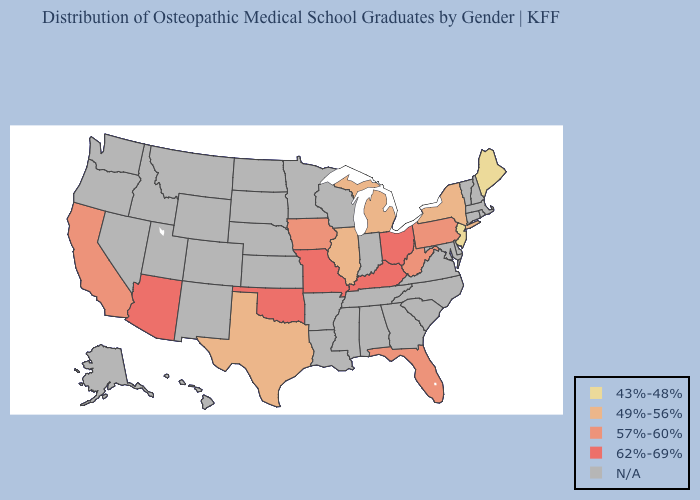What is the highest value in states that border Delaware?
Short answer required. 57%-60%. Name the states that have a value in the range 49%-56%?
Give a very brief answer. Illinois, Michigan, New York, Texas. Among the states that border Indiana , which have the lowest value?
Quick response, please. Illinois, Michigan. Does Texas have the lowest value in the South?
Give a very brief answer. Yes. What is the value of Louisiana?
Short answer required. N/A. Name the states that have a value in the range 49%-56%?
Keep it brief. Illinois, Michigan, New York, Texas. Name the states that have a value in the range 57%-60%?
Keep it brief. California, Florida, Iowa, Pennsylvania, West Virginia. Which states have the lowest value in the West?
Keep it brief. California. What is the value of Alaska?
Answer briefly. N/A. Name the states that have a value in the range 43%-48%?
Be succinct. Maine, New Jersey. What is the lowest value in states that border Pennsylvania?
Write a very short answer. 43%-48%. Name the states that have a value in the range 43%-48%?
Give a very brief answer. Maine, New Jersey. 